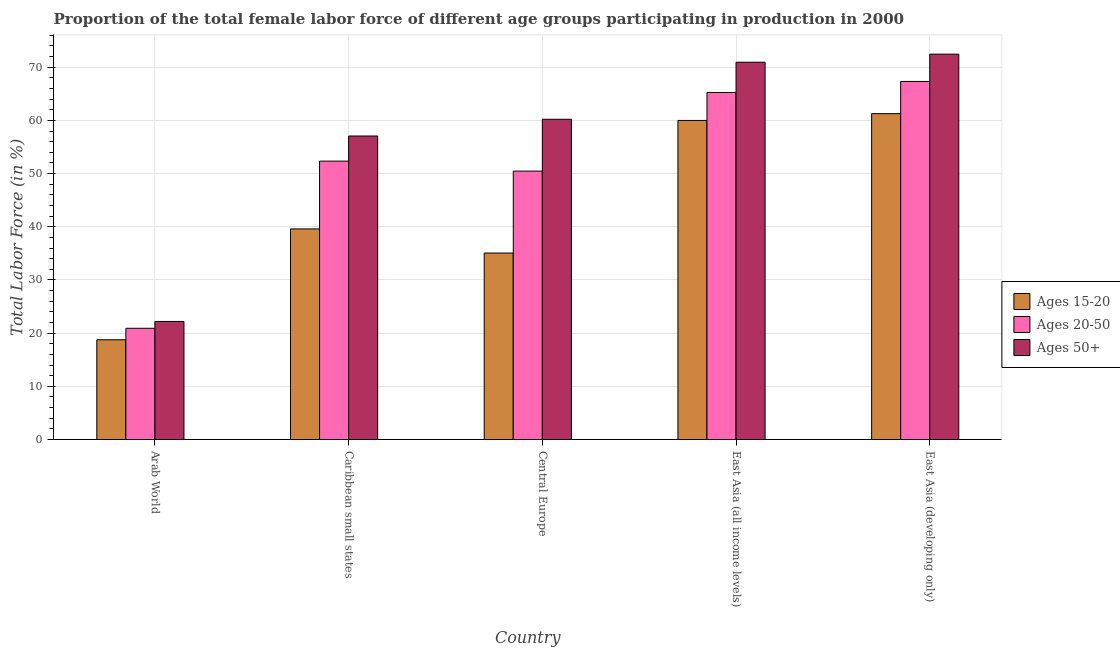How many groups of bars are there?
Ensure brevity in your answer.  5. Are the number of bars per tick equal to the number of legend labels?
Provide a short and direct response. Yes. Are the number of bars on each tick of the X-axis equal?
Make the answer very short. Yes. How many bars are there on the 5th tick from the left?
Offer a terse response. 3. How many bars are there on the 4th tick from the right?
Your answer should be very brief. 3. What is the label of the 3rd group of bars from the left?
Provide a short and direct response. Central Europe. What is the percentage of female labor force within the age group 20-50 in East Asia (developing only)?
Ensure brevity in your answer.  67.32. Across all countries, what is the maximum percentage of female labor force above age 50?
Your answer should be very brief. 72.45. Across all countries, what is the minimum percentage of female labor force above age 50?
Make the answer very short. 22.2. In which country was the percentage of female labor force above age 50 maximum?
Offer a very short reply. East Asia (developing only). In which country was the percentage of female labor force within the age group 15-20 minimum?
Make the answer very short. Arab World. What is the total percentage of female labor force within the age group 15-20 in the graph?
Provide a succinct answer. 214.65. What is the difference between the percentage of female labor force within the age group 20-50 in Central Europe and that in East Asia (all income levels)?
Provide a short and direct response. -14.78. What is the difference between the percentage of female labor force within the age group 20-50 in Caribbean small states and the percentage of female labor force within the age group 15-20 in Central Europe?
Your answer should be very brief. 17.28. What is the average percentage of female labor force within the age group 15-20 per country?
Provide a short and direct response. 42.93. What is the difference between the percentage of female labor force within the age group 15-20 and percentage of female labor force within the age group 20-50 in East Asia (all income levels)?
Provide a succinct answer. -5.25. What is the ratio of the percentage of female labor force within the age group 20-50 in Central Europe to that in East Asia (all income levels)?
Provide a succinct answer. 0.77. Is the percentage of female labor force above age 50 in Central Europe less than that in East Asia (developing only)?
Your answer should be compact. Yes. What is the difference between the highest and the second highest percentage of female labor force within the age group 15-20?
Your answer should be compact. 1.28. What is the difference between the highest and the lowest percentage of female labor force within the age group 15-20?
Make the answer very short. 42.51. In how many countries, is the percentage of female labor force within the age group 15-20 greater than the average percentage of female labor force within the age group 15-20 taken over all countries?
Offer a terse response. 2. What does the 3rd bar from the left in East Asia (developing only) represents?
Provide a short and direct response. Ages 50+. What does the 2nd bar from the right in Central Europe represents?
Give a very brief answer. Ages 20-50. Is it the case that in every country, the sum of the percentage of female labor force within the age group 15-20 and percentage of female labor force within the age group 20-50 is greater than the percentage of female labor force above age 50?
Your answer should be very brief. Yes. How many bars are there?
Offer a very short reply. 15. How many countries are there in the graph?
Offer a terse response. 5. What is the difference between two consecutive major ticks on the Y-axis?
Your answer should be very brief. 10. How are the legend labels stacked?
Make the answer very short. Vertical. What is the title of the graph?
Offer a terse response. Proportion of the total female labor force of different age groups participating in production in 2000. Does "Wage workers" appear as one of the legend labels in the graph?
Your answer should be compact. No. What is the Total Labor Force (in %) in Ages 15-20 in Arab World?
Your response must be concise. 18.75. What is the Total Labor Force (in %) in Ages 20-50 in Arab World?
Offer a terse response. 20.91. What is the Total Labor Force (in %) in Ages 50+ in Arab World?
Provide a short and direct response. 22.2. What is the Total Labor Force (in %) in Ages 15-20 in Caribbean small states?
Ensure brevity in your answer.  39.59. What is the Total Labor Force (in %) in Ages 20-50 in Caribbean small states?
Provide a short and direct response. 52.34. What is the Total Labor Force (in %) in Ages 50+ in Caribbean small states?
Your answer should be very brief. 57.06. What is the Total Labor Force (in %) of Ages 15-20 in Central Europe?
Your answer should be very brief. 35.06. What is the Total Labor Force (in %) in Ages 20-50 in Central Europe?
Keep it short and to the point. 50.46. What is the Total Labor Force (in %) in Ages 50+ in Central Europe?
Ensure brevity in your answer.  60.21. What is the Total Labor Force (in %) of Ages 15-20 in East Asia (all income levels)?
Provide a short and direct response. 59.99. What is the Total Labor Force (in %) in Ages 20-50 in East Asia (all income levels)?
Offer a very short reply. 65.24. What is the Total Labor Force (in %) of Ages 50+ in East Asia (all income levels)?
Provide a succinct answer. 70.93. What is the Total Labor Force (in %) of Ages 15-20 in East Asia (developing only)?
Your answer should be compact. 61.26. What is the Total Labor Force (in %) of Ages 20-50 in East Asia (developing only)?
Your answer should be compact. 67.32. What is the Total Labor Force (in %) in Ages 50+ in East Asia (developing only)?
Your response must be concise. 72.45. Across all countries, what is the maximum Total Labor Force (in %) in Ages 15-20?
Provide a short and direct response. 61.26. Across all countries, what is the maximum Total Labor Force (in %) in Ages 20-50?
Your answer should be very brief. 67.32. Across all countries, what is the maximum Total Labor Force (in %) in Ages 50+?
Offer a terse response. 72.45. Across all countries, what is the minimum Total Labor Force (in %) in Ages 15-20?
Offer a terse response. 18.75. Across all countries, what is the minimum Total Labor Force (in %) of Ages 20-50?
Provide a short and direct response. 20.91. Across all countries, what is the minimum Total Labor Force (in %) in Ages 50+?
Provide a succinct answer. 22.2. What is the total Total Labor Force (in %) of Ages 15-20 in the graph?
Give a very brief answer. 214.65. What is the total Total Labor Force (in %) of Ages 20-50 in the graph?
Your response must be concise. 256.27. What is the total Total Labor Force (in %) in Ages 50+ in the graph?
Offer a very short reply. 282.85. What is the difference between the Total Labor Force (in %) in Ages 15-20 in Arab World and that in Caribbean small states?
Offer a terse response. -20.84. What is the difference between the Total Labor Force (in %) of Ages 20-50 in Arab World and that in Caribbean small states?
Keep it short and to the point. -31.43. What is the difference between the Total Labor Force (in %) in Ages 50+ in Arab World and that in Caribbean small states?
Your answer should be very brief. -34.86. What is the difference between the Total Labor Force (in %) of Ages 15-20 in Arab World and that in Central Europe?
Your response must be concise. -16.31. What is the difference between the Total Labor Force (in %) in Ages 20-50 in Arab World and that in Central Europe?
Give a very brief answer. -29.55. What is the difference between the Total Labor Force (in %) of Ages 50+ in Arab World and that in Central Europe?
Offer a very short reply. -38.01. What is the difference between the Total Labor Force (in %) in Ages 15-20 in Arab World and that in East Asia (all income levels)?
Ensure brevity in your answer.  -41.23. What is the difference between the Total Labor Force (in %) of Ages 20-50 in Arab World and that in East Asia (all income levels)?
Provide a short and direct response. -44.33. What is the difference between the Total Labor Force (in %) of Ages 50+ in Arab World and that in East Asia (all income levels)?
Keep it short and to the point. -48.74. What is the difference between the Total Labor Force (in %) in Ages 15-20 in Arab World and that in East Asia (developing only)?
Your answer should be compact. -42.51. What is the difference between the Total Labor Force (in %) in Ages 20-50 in Arab World and that in East Asia (developing only)?
Your answer should be very brief. -46.41. What is the difference between the Total Labor Force (in %) of Ages 50+ in Arab World and that in East Asia (developing only)?
Your answer should be very brief. -50.25. What is the difference between the Total Labor Force (in %) of Ages 15-20 in Caribbean small states and that in Central Europe?
Ensure brevity in your answer.  4.53. What is the difference between the Total Labor Force (in %) in Ages 20-50 in Caribbean small states and that in Central Europe?
Your response must be concise. 1.88. What is the difference between the Total Labor Force (in %) in Ages 50+ in Caribbean small states and that in Central Europe?
Your answer should be compact. -3.15. What is the difference between the Total Labor Force (in %) in Ages 15-20 in Caribbean small states and that in East Asia (all income levels)?
Your answer should be compact. -20.39. What is the difference between the Total Labor Force (in %) in Ages 20-50 in Caribbean small states and that in East Asia (all income levels)?
Give a very brief answer. -12.9. What is the difference between the Total Labor Force (in %) in Ages 50+ in Caribbean small states and that in East Asia (all income levels)?
Provide a short and direct response. -13.87. What is the difference between the Total Labor Force (in %) of Ages 15-20 in Caribbean small states and that in East Asia (developing only)?
Provide a succinct answer. -21.67. What is the difference between the Total Labor Force (in %) of Ages 20-50 in Caribbean small states and that in East Asia (developing only)?
Your response must be concise. -14.98. What is the difference between the Total Labor Force (in %) in Ages 50+ in Caribbean small states and that in East Asia (developing only)?
Make the answer very short. -15.39. What is the difference between the Total Labor Force (in %) of Ages 15-20 in Central Europe and that in East Asia (all income levels)?
Your answer should be compact. -24.93. What is the difference between the Total Labor Force (in %) of Ages 20-50 in Central Europe and that in East Asia (all income levels)?
Your answer should be compact. -14.78. What is the difference between the Total Labor Force (in %) of Ages 50+ in Central Europe and that in East Asia (all income levels)?
Make the answer very short. -10.73. What is the difference between the Total Labor Force (in %) in Ages 15-20 in Central Europe and that in East Asia (developing only)?
Keep it short and to the point. -26.2. What is the difference between the Total Labor Force (in %) of Ages 20-50 in Central Europe and that in East Asia (developing only)?
Provide a succinct answer. -16.86. What is the difference between the Total Labor Force (in %) in Ages 50+ in Central Europe and that in East Asia (developing only)?
Provide a succinct answer. -12.24. What is the difference between the Total Labor Force (in %) in Ages 15-20 in East Asia (all income levels) and that in East Asia (developing only)?
Give a very brief answer. -1.28. What is the difference between the Total Labor Force (in %) of Ages 20-50 in East Asia (all income levels) and that in East Asia (developing only)?
Offer a very short reply. -2.08. What is the difference between the Total Labor Force (in %) of Ages 50+ in East Asia (all income levels) and that in East Asia (developing only)?
Your answer should be very brief. -1.52. What is the difference between the Total Labor Force (in %) in Ages 15-20 in Arab World and the Total Labor Force (in %) in Ages 20-50 in Caribbean small states?
Your answer should be compact. -33.59. What is the difference between the Total Labor Force (in %) in Ages 15-20 in Arab World and the Total Labor Force (in %) in Ages 50+ in Caribbean small states?
Your answer should be compact. -38.31. What is the difference between the Total Labor Force (in %) of Ages 20-50 in Arab World and the Total Labor Force (in %) of Ages 50+ in Caribbean small states?
Your answer should be compact. -36.15. What is the difference between the Total Labor Force (in %) of Ages 15-20 in Arab World and the Total Labor Force (in %) of Ages 20-50 in Central Europe?
Your answer should be very brief. -31.71. What is the difference between the Total Labor Force (in %) in Ages 15-20 in Arab World and the Total Labor Force (in %) in Ages 50+ in Central Europe?
Make the answer very short. -41.45. What is the difference between the Total Labor Force (in %) of Ages 20-50 in Arab World and the Total Labor Force (in %) of Ages 50+ in Central Europe?
Offer a very short reply. -39.3. What is the difference between the Total Labor Force (in %) in Ages 15-20 in Arab World and the Total Labor Force (in %) in Ages 20-50 in East Asia (all income levels)?
Your answer should be compact. -46.49. What is the difference between the Total Labor Force (in %) in Ages 15-20 in Arab World and the Total Labor Force (in %) in Ages 50+ in East Asia (all income levels)?
Your answer should be very brief. -52.18. What is the difference between the Total Labor Force (in %) in Ages 20-50 in Arab World and the Total Labor Force (in %) in Ages 50+ in East Asia (all income levels)?
Keep it short and to the point. -50.02. What is the difference between the Total Labor Force (in %) in Ages 15-20 in Arab World and the Total Labor Force (in %) in Ages 20-50 in East Asia (developing only)?
Provide a short and direct response. -48.57. What is the difference between the Total Labor Force (in %) in Ages 15-20 in Arab World and the Total Labor Force (in %) in Ages 50+ in East Asia (developing only)?
Provide a short and direct response. -53.7. What is the difference between the Total Labor Force (in %) of Ages 20-50 in Arab World and the Total Labor Force (in %) of Ages 50+ in East Asia (developing only)?
Your answer should be compact. -51.54. What is the difference between the Total Labor Force (in %) of Ages 15-20 in Caribbean small states and the Total Labor Force (in %) of Ages 20-50 in Central Europe?
Your answer should be very brief. -10.87. What is the difference between the Total Labor Force (in %) of Ages 15-20 in Caribbean small states and the Total Labor Force (in %) of Ages 50+ in Central Europe?
Give a very brief answer. -20.61. What is the difference between the Total Labor Force (in %) in Ages 20-50 in Caribbean small states and the Total Labor Force (in %) in Ages 50+ in Central Europe?
Keep it short and to the point. -7.87. What is the difference between the Total Labor Force (in %) in Ages 15-20 in Caribbean small states and the Total Labor Force (in %) in Ages 20-50 in East Asia (all income levels)?
Provide a succinct answer. -25.65. What is the difference between the Total Labor Force (in %) of Ages 15-20 in Caribbean small states and the Total Labor Force (in %) of Ages 50+ in East Asia (all income levels)?
Give a very brief answer. -31.34. What is the difference between the Total Labor Force (in %) of Ages 20-50 in Caribbean small states and the Total Labor Force (in %) of Ages 50+ in East Asia (all income levels)?
Your response must be concise. -18.59. What is the difference between the Total Labor Force (in %) of Ages 15-20 in Caribbean small states and the Total Labor Force (in %) of Ages 20-50 in East Asia (developing only)?
Keep it short and to the point. -27.73. What is the difference between the Total Labor Force (in %) in Ages 15-20 in Caribbean small states and the Total Labor Force (in %) in Ages 50+ in East Asia (developing only)?
Ensure brevity in your answer.  -32.86. What is the difference between the Total Labor Force (in %) of Ages 20-50 in Caribbean small states and the Total Labor Force (in %) of Ages 50+ in East Asia (developing only)?
Give a very brief answer. -20.11. What is the difference between the Total Labor Force (in %) in Ages 15-20 in Central Europe and the Total Labor Force (in %) in Ages 20-50 in East Asia (all income levels)?
Give a very brief answer. -30.18. What is the difference between the Total Labor Force (in %) of Ages 15-20 in Central Europe and the Total Labor Force (in %) of Ages 50+ in East Asia (all income levels)?
Your answer should be very brief. -35.87. What is the difference between the Total Labor Force (in %) in Ages 20-50 in Central Europe and the Total Labor Force (in %) in Ages 50+ in East Asia (all income levels)?
Offer a terse response. -20.47. What is the difference between the Total Labor Force (in %) in Ages 15-20 in Central Europe and the Total Labor Force (in %) in Ages 20-50 in East Asia (developing only)?
Offer a terse response. -32.26. What is the difference between the Total Labor Force (in %) of Ages 15-20 in Central Europe and the Total Labor Force (in %) of Ages 50+ in East Asia (developing only)?
Your response must be concise. -37.39. What is the difference between the Total Labor Force (in %) in Ages 20-50 in Central Europe and the Total Labor Force (in %) in Ages 50+ in East Asia (developing only)?
Offer a terse response. -21.99. What is the difference between the Total Labor Force (in %) of Ages 15-20 in East Asia (all income levels) and the Total Labor Force (in %) of Ages 20-50 in East Asia (developing only)?
Keep it short and to the point. -7.33. What is the difference between the Total Labor Force (in %) of Ages 15-20 in East Asia (all income levels) and the Total Labor Force (in %) of Ages 50+ in East Asia (developing only)?
Your response must be concise. -12.46. What is the difference between the Total Labor Force (in %) in Ages 20-50 in East Asia (all income levels) and the Total Labor Force (in %) in Ages 50+ in East Asia (developing only)?
Offer a terse response. -7.21. What is the average Total Labor Force (in %) in Ages 15-20 per country?
Offer a very short reply. 42.93. What is the average Total Labor Force (in %) in Ages 20-50 per country?
Provide a succinct answer. 51.25. What is the average Total Labor Force (in %) in Ages 50+ per country?
Make the answer very short. 56.57. What is the difference between the Total Labor Force (in %) of Ages 15-20 and Total Labor Force (in %) of Ages 20-50 in Arab World?
Offer a terse response. -2.16. What is the difference between the Total Labor Force (in %) in Ages 15-20 and Total Labor Force (in %) in Ages 50+ in Arab World?
Keep it short and to the point. -3.44. What is the difference between the Total Labor Force (in %) of Ages 20-50 and Total Labor Force (in %) of Ages 50+ in Arab World?
Ensure brevity in your answer.  -1.28. What is the difference between the Total Labor Force (in %) of Ages 15-20 and Total Labor Force (in %) of Ages 20-50 in Caribbean small states?
Your answer should be very brief. -12.75. What is the difference between the Total Labor Force (in %) of Ages 15-20 and Total Labor Force (in %) of Ages 50+ in Caribbean small states?
Give a very brief answer. -17.47. What is the difference between the Total Labor Force (in %) in Ages 20-50 and Total Labor Force (in %) in Ages 50+ in Caribbean small states?
Give a very brief answer. -4.72. What is the difference between the Total Labor Force (in %) in Ages 15-20 and Total Labor Force (in %) in Ages 20-50 in Central Europe?
Your answer should be very brief. -15.4. What is the difference between the Total Labor Force (in %) in Ages 15-20 and Total Labor Force (in %) in Ages 50+ in Central Europe?
Make the answer very short. -25.15. What is the difference between the Total Labor Force (in %) of Ages 20-50 and Total Labor Force (in %) of Ages 50+ in Central Europe?
Give a very brief answer. -9.75. What is the difference between the Total Labor Force (in %) in Ages 15-20 and Total Labor Force (in %) in Ages 20-50 in East Asia (all income levels)?
Provide a succinct answer. -5.25. What is the difference between the Total Labor Force (in %) of Ages 15-20 and Total Labor Force (in %) of Ages 50+ in East Asia (all income levels)?
Provide a short and direct response. -10.95. What is the difference between the Total Labor Force (in %) in Ages 20-50 and Total Labor Force (in %) in Ages 50+ in East Asia (all income levels)?
Ensure brevity in your answer.  -5.69. What is the difference between the Total Labor Force (in %) in Ages 15-20 and Total Labor Force (in %) in Ages 20-50 in East Asia (developing only)?
Make the answer very short. -6.06. What is the difference between the Total Labor Force (in %) in Ages 15-20 and Total Labor Force (in %) in Ages 50+ in East Asia (developing only)?
Your response must be concise. -11.19. What is the difference between the Total Labor Force (in %) in Ages 20-50 and Total Labor Force (in %) in Ages 50+ in East Asia (developing only)?
Provide a short and direct response. -5.13. What is the ratio of the Total Labor Force (in %) in Ages 15-20 in Arab World to that in Caribbean small states?
Your answer should be very brief. 0.47. What is the ratio of the Total Labor Force (in %) in Ages 20-50 in Arab World to that in Caribbean small states?
Offer a terse response. 0.4. What is the ratio of the Total Labor Force (in %) of Ages 50+ in Arab World to that in Caribbean small states?
Your response must be concise. 0.39. What is the ratio of the Total Labor Force (in %) in Ages 15-20 in Arab World to that in Central Europe?
Make the answer very short. 0.53. What is the ratio of the Total Labor Force (in %) of Ages 20-50 in Arab World to that in Central Europe?
Make the answer very short. 0.41. What is the ratio of the Total Labor Force (in %) in Ages 50+ in Arab World to that in Central Europe?
Ensure brevity in your answer.  0.37. What is the ratio of the Total Labor Force (in %) of Ages 15-20 in Arab World to that in East Asia (all income levels)?
Your response must be concise. 0.31. What is the ratio of the Total Labor Force (in %) in Ages 20-50 in Arab World to that in East Asia (all income levels)?
Your response must be concise. 0.32. What is the ratio of the Total Labor Force (in %) in Ages 50+ in Arab World to that in East Asia (all income levels)?
Provide a succinct answer. 0.31. What is the ratio of the Total Labor Force (in %) in Ages 15-20 in Arab World to that in East Asia (developing only)?
Ensure brevity in your answer.  0.31. What is the ratio of the Total Labor Force (in %) in Ages 20-50 in Arab World to that in East Asia (developing only)?
Provide a short and direct response. 0.31. What is the ratio of the Total Labor Force (in %) of Ages 50+ in Arab World to that in East Asia (developing only)?
Offer a very short reply. 0.31. What is the ratio of the Total Labor Force (in %) in Ages 15-20 in Caribbean small states to that in Central Europe?
Give a very brief answer. 1.13. What is the ratio of the Total Labor Force (in %) of Ages 20-50 in Caribbean small states to that in Central Europe?
Make the answer very short. 1.04. What is the ratio of the Total Labor Force (in %) of Ages 50+ in Caribbean small states to that in Central Europe?
Give a very brief answer. 0.95. What is the ratio of the Total Labor Force (in %) in Ages 15-20 in Caribbean small states to that in East Asia (all income levels)?
Ensure brevity in your answer.  0.66. What is the ratio of the Total Labor Force (in %) of Ages 20-50 in Caribbean small states to that in East Asia (all income levels)?
Your response must be concise. 0.8. What is the ratio of the Total Labor Force (in %) in Ages 50+ in Caribbean small states to that in East Asia (all income levels)?
Your answer should be compact. 0.8. What is the ratio of the Total Labor Force (in %) of Ages 15-20 in Caribbean small states to that in East Asia (developing only)?
Offer a very short reply. 0.65. What is the ratio of the Total Labor Force (in %) of Ages 20-50 in Caribbean small states to that in East Asia (developing only)?
Provide a short and direct response. 0.78. What is the ratio of the Total Labor Force (in %) in Ages 50+ in Caribbean small states to that in East Asia (developing only)?
Ensure brevity in your answer.  0.79. What is the ratio of the Total Labor Force (in %) of Ages 15-20 in Central Europe to that in East Asia (all income levels)?
Offer a very short reply. 0.58. What is the ratio of the Total Labor Force (in %) of Ages 20-50 in Central Europe to that in East Asia (all income levels)?
Your answer should be very brief. 0.77. What is the ratio of the Total Labor Force (in %) of Ages 50+ in Central Europe to that in East Asia (all income levels)?
Make the answer very short. 0.85. What is the ratio of the Total Labor Force (in %) of Ages 15-20 in Central Europe to that in East Asia (developing only)?
Ensure brevity in your answer.  0.57. What is the ratio of the Total Labor Force (in %) of Ages 20-50 in Central Europe to that in East Asia (developing only)?
Offer a very short reply. 0.75. What is the ratio of the Total Labor Force (in %) of Ages 50+ in Central Europe to that in East Asia (developing only)?
Offer a very short reply. 0.83. What is the ratio of the Total Labor Force (in %) in Ages 15-20 in East Asia (all income levels) to that in East Asia (developing only)?
Provide a short and direct response. 0.98. What is the ratio of the Total Labor Force (in %) in Ages 20-50 in East Asia (all income levels) to that in East Asia (developing only)?
Your answer should be very brief. 0.97. What is the ratio of the Total Labor Force (in %) in Ages 50+ in East Asia (all income levels) to that in East Asia (developing only)?
Offer a very short reply. 0.98. What is the difference between the highest and the second highest Total Labor Force (in %) in Ages 15-20?
Ensure brevity in your answer.  1.28. What is the difference between the highest and the second highest Total Labor Force (in %) of Ages 20-50?
Keep it short and to the point. 2.08. What is the difference between the highest and the second highest Total Labor Force (in %) in Ages 50+?
Make the answer very short. 1.52. What is the difference between the highest and the lowest Total Labor Force (in %) in Ages 15-20?
Provide a succinct answer. 42.51. What is the difference between the highest and the lowest Total Labor Force (in %) of Ages 20-50?
Ensure brevity in your answer.  46.41. What is the difference between the highest and the lowest Total Labor Force (in %) of Ages 50+?
Give a very brief answer. 50.25. 